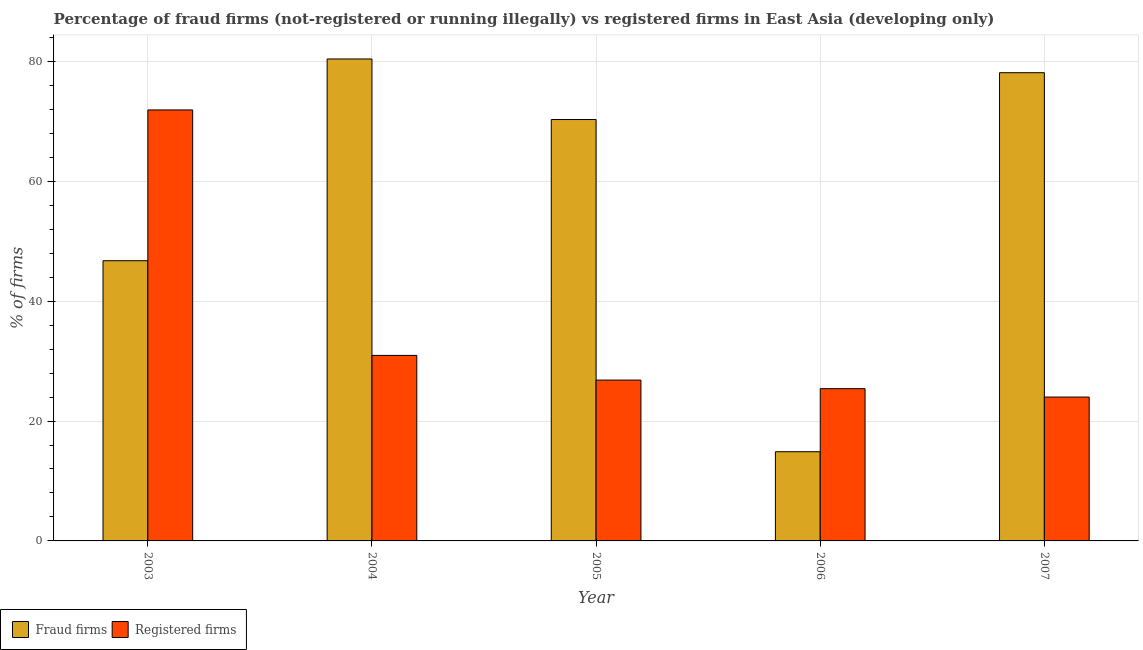How many groups of bars are there?
Offer a very short reply. 5. How many bars are there on the 2nd tick from the left?
Give a very brief answer. 2. What is the percentage of registered firms in 2003?
Ensure brevity in your answer.  71.9. Across all years, what is the maximum percentage of registered firms?
Give a very brief answer. 71.9. Across all years, what is the minimum percentage of fraud firms?
Ensure brevity in your answer.  14.88. What is the total percentage of fraud firms in the graph?
Your answer should be very brief. 290.44. What is the difference between the percentage of registered firms in 2005 and that in 2007?
Make the answer very short. 2.83. What is the difference between the percentage of registered firms in 2005 and the percentage of fraud firms in 2004?
Your answer should be compact. -4.12. What is the average percentage of registered firms per year?
Your answer should be compact. 35.82. What is the ratio of the percentage of registered firms in 2003 to that in 2007?
Offer a very short reply. 3. What is the difference between the highest and the second highest percentage of fraud firms?
Give a very brief answer. 2.29. What is the difference between the highest and the lowest percentage of registered firms?
Offer a very short reply. 47.9. Is the sum of the percentage of registered firms in 2004 and 2005 greater than the maximum percentage of fraud firms across all years?
Provide a short and direct response. No. What does the 1st bar from the left in 2007 represents?
Your answer should be very brief. Fraud firms. What does the 2nd bar from the right in 2006 represents?
Your answer should be very brief. Fraud firms. What is the difference between two consecutive major ticks on the Y-axis?
Your answer should be compact. 20. Does the graph contain any zero values?
Make the answer very short. No. What is the title of the graph?
Provide a succinct answer. Percentage of fraud firms (not-registered or running illegally) vs registered firms in East Asia (developing only). Does "Services" appear as one of the legend labels in the graph?
Offer a terse response. No. What is the label or title of the Y-axis?
Ensure brevity in your answer.  % of firms. What is the % of firms of Fraud firms in 2003?
Provide a short and direct response. 46.74. What is the % of firms in Registered firms in 2003?
Your response must be concise. 71.9. What is the % of firms in Fraud firms in 2004?
Ensure brevity in your answer.  80.4. What is the % of firms in Registered firms in 2004?
Offer a terse response. 30.95. What is the % of firms of Fraud firms in 2005?
Keep it short and to the point. 70.3. What is the % of firms in Registered firms in 2005?
Offer a terse response. 26.83. What is the % of firms in Fraud firms in 2006?
Your answer should be compact. 14.88. What is the % of firms of Registered firms in 2006?
Make the answer very short. 25.4. What is the % of firms of Fraud firms in 2007?
Ensure brevity in your answer.  78.11. What is the % of firms of Registered firms in 2007?
Offer a terse response. 24. Across all years, what is the maximum % of firms of Fraud firms?
Offer a very short reply. 80.4. Across all years, what is the maximum % of firms of Registered firms?
Offer a terse response. 71.9. Across all years, what is the minimum % of firms in Fraud firms?
Offer a terse response. 14.88. Across all years, what is the minimum % of firms of Registered firms?
Provide a succinct answer. 24. What is the total % of firms in Fraud firms in the graph?
Your answer should be compact. 290.44. What is the total % of firms of Registered firms in the graph?
Provide a short and direct response. 179.08. What is the difference between the % of firms of Fraud firms in 2003 and that in 2004?
Ensure brevity in your answer.  -33.66. What is the difference between the % of firms in Registered firms in 2003 and that in 2004?
Ensure brevity in your answer.  40.95. What is the difference between the % of firms of Fraud firms in 2003 and that in 2005?
Give a very brief answer. -23.55. What is the difference between the % of firms in Registered firms in 2003 and that in 2005?
Keep it short and to the point. 45.07. What is the difference between the % of firms of Fraud firms in 2003 and that in 2006?
Keep it short and to the point. 31.86. What is the difference between the % of firms of Registered firms in 2003 and that in 2006?
Keep it short and to the point. 46.5. What is the difference between the % of firms in Fraud firms in 2003 and that in 2007?
Keep it short and to the point. -31.36. What is the difference between the % of firms of Registered firms in 2003 and that in 2007?
Provide a short and direct response. 47.9. What is the difference between the % of firms of Registered firms in 2004 and that in 2005?
Your answer should be compact. 4.12. What is the difference between the % of firms of Fraud firms in 2004 and that in 2006?
Give a very brief answer. 65.52. What is the difference between the % of firms in Registered firms in 2004 and that in 2006?
Make the answer very short. 5.55. What is the difference between the % of firms in Fraud firms in 2004 and that in 2007?
Provide a short and direct response. 2.29. What is the difference between the % of firms in Registered firms in 2004 and that in 2007?
Offer a very short reply. 6.95. What is the difference between the % of firms in Fraud firms in 2005 and that in 2006?
Make the answer very short. 55.42. What is the difference between the % of firms of Registered firms in 2005 and that in 2006?
Keep it short and to the point. 1.43. What is the difference between the % of firms in Fraud firms in 2005 and that in 2007?
Your answer should be very brief. -7.81. What is the difference between the % of firms of Registered firms in 2005 and that in 2007?
Give a very brief answer. 2.83. What is the difference between the % of firms in Fraud firms in 2006 and that in 2007?
Give a very brief answer. -63.23. What is the difference between the % of firms in Registered firms in 2006 and that in 2007?
Ensure brevity in your answer.  1.4. What is the difference between the % of firms of Fraud firms in 2003 and the % of firms of Registered firms in 2004?
Your response must be concise. 15.79. What is the difference between the % of firms of Fraud firms in 2003 and the % of firms of Registered firms in 2005?
Offer a terse response. 19.91. What is the difference between the % of firms of Fraud firms in 2003 and the % of firms of Registered firms in 2006?
Offer a terse response. 21.34. What is the difference between the % of firms of Fraud firms in 2003 and the % of firms of Registered firms in 2007?
Offer a terse response. 22.75. What is the difference between the % of firms in Fraud firms in 2004 and the % of firms in Registered firms in 2005?
Keep it short and to the point. 53.57. What is the difference between the % of firms of Fraud firms in 2004 and the % of firms of Registered firms in 2007?
Keep it short and to the point. 56.4. What is the difference between the % of firms in Fraud firms in 2005 and the % of firms in Registered firms in 2006?
Your answer should be very brief. 44.9. What is the difference between the % of firms of Fraud firms in 2005 and the % of firms of Registered firms in 2007?
Provide a short and direct response. 46.3. What is the difference between the % of firms of Fraud firms in 2006 and the % of firms of Registered firms in 2007?
Give a very brief answer. -9.12. What is the average % of firms of Fraud firms per year?
Ensure brevity in your answer.  58.09. What is the average % of firms in Registered firms per year?
Ensure brevity in your answer.  35.82. In the year 2003, what is the difference between the % of firms in Fraud firms and % of firms in Registered firms?
Your answer should be very brief. -25.16. In the year 2004, what is the difference between the % of firms of Fraud firms and % of firms of Registered firms?
Your answer should be very brief. 49.45. In the year 2005, what is the difference between the % of firms of Fraud firms and % of firms of Registered firms?
Keep it short and to the point. 43.47. In the year 2006, what is the difference between the % of firms in Fraud firms and % of firms in Registered firms?
Your answer should be very brief. -10.52. In the year 2007, what is the difference between the % of firms in Fraud firms and % of firms in Registered firms?
Offer a terse response. 54.11. What is the ratio of the % of firms of Fraud firms in 2003 to that in 2004?
Ensure brevity in your answer.  0.58. What is the ratio of the % of firms of Registered firms in 2003 to that in 2004?
Provide a short and direct response. 2.32. What is the ratio of the % of firms in Fraud firms in 2003 to that in 2005?
Provide a short and direct response. 0.66. What is the ratio of the % of firms of Registered firms in 2003 to that in 2005?
Provide a succinct answer. 2.68. What is the ratio of the % of firms of Fraud firms in 2003 to that in 2006?
Offer a very short reply. 3.14. What is the ratio of the % of firms of Registered firms in 2003 to that in 2006?
Ensure brevity in your answer.  2.83. What is the ratio of the % of firms in Fraud firms in 2003 to that in 2007?
Your answer should be compact. 0.6. What is the ratio of the % of firms in Registered firms in 2003 to that in 2007?
Offer a terse response. 3. What is the ratio of the % of firms in Fraud firms in 2004 to that in 2005?
Provide a short and direct response. 1.14. What is the ratio of the % of firms in Registered firms in 2004 to that in 2005?
Keep it short and to the point. 1.15. What is the ratio of the % of firms of Fraud firms in 2004 to that in 2006?
Your answer should be compact. 5.4. What is the ratio of the % of firms in Registered firms in 2004 to that in 2006?
Ensure brevity in your answer.  1.22. What is the ratio of the % of firms of Fraud firms in 2004 to that in 2007?
Your response must be concise. 1.03. What is the ratio of the % of firms in Registered firms in 2004 to that in 2007?
Your answer should be very brief. 1.29. What is the ratio of the % of firms in Fraud firms in 2005 to that in 2006?
Offer a very short reply. 4.72. What is the ratio of the % of firms in Registered firms in 2005 to that in 2006?
Provide a succinct answer. 1.06. What is the ratio of the % of firms of Registered firms in 2005 to that in 2007?
Your answer should be very brief. 1.12. What is the ratio of the % of firms of Fraud firms in 2006 to that in 2007?
Your response must be concise. 0.19. What is the ratio of the % of firms in Registered firms in 2006 to that in 2007?
Offer a very short reply. 1.06. What is the difference between the highest and the second highest % of firms of Fraud firms?
Make the answer very short. 2.29. What is the difference between the highest and the second highest % of firms of Registered firms?
Your answer should be compact. 40.95. What is the difference between the highest and the lowest % of firms in Fraud firms?
Provide a short and direct response. 65.52. What is the difference between the highest and the lowest % of firms of Registered firms?
Your response must be concise. 47.9. 